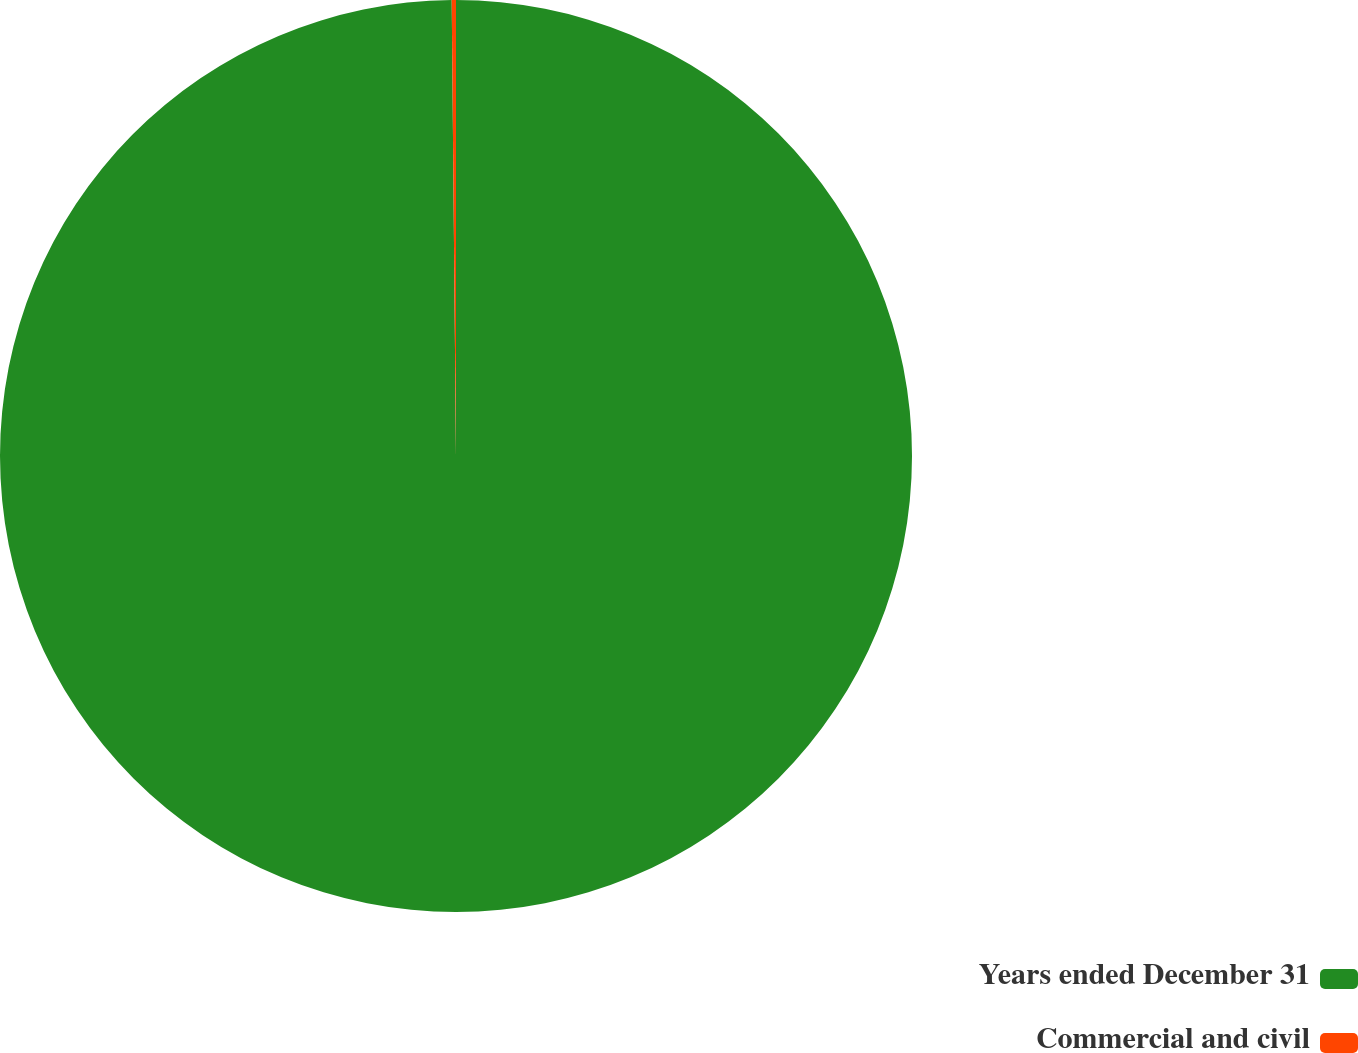Convert chart. <chart><loc_0><loc_0><loc_500><loc_500><pie_chart><fcel>Years ended December 31<fcel>Commercial and civil<nl><fcel>99.85%<fcel>0.15%<nl></chart> 